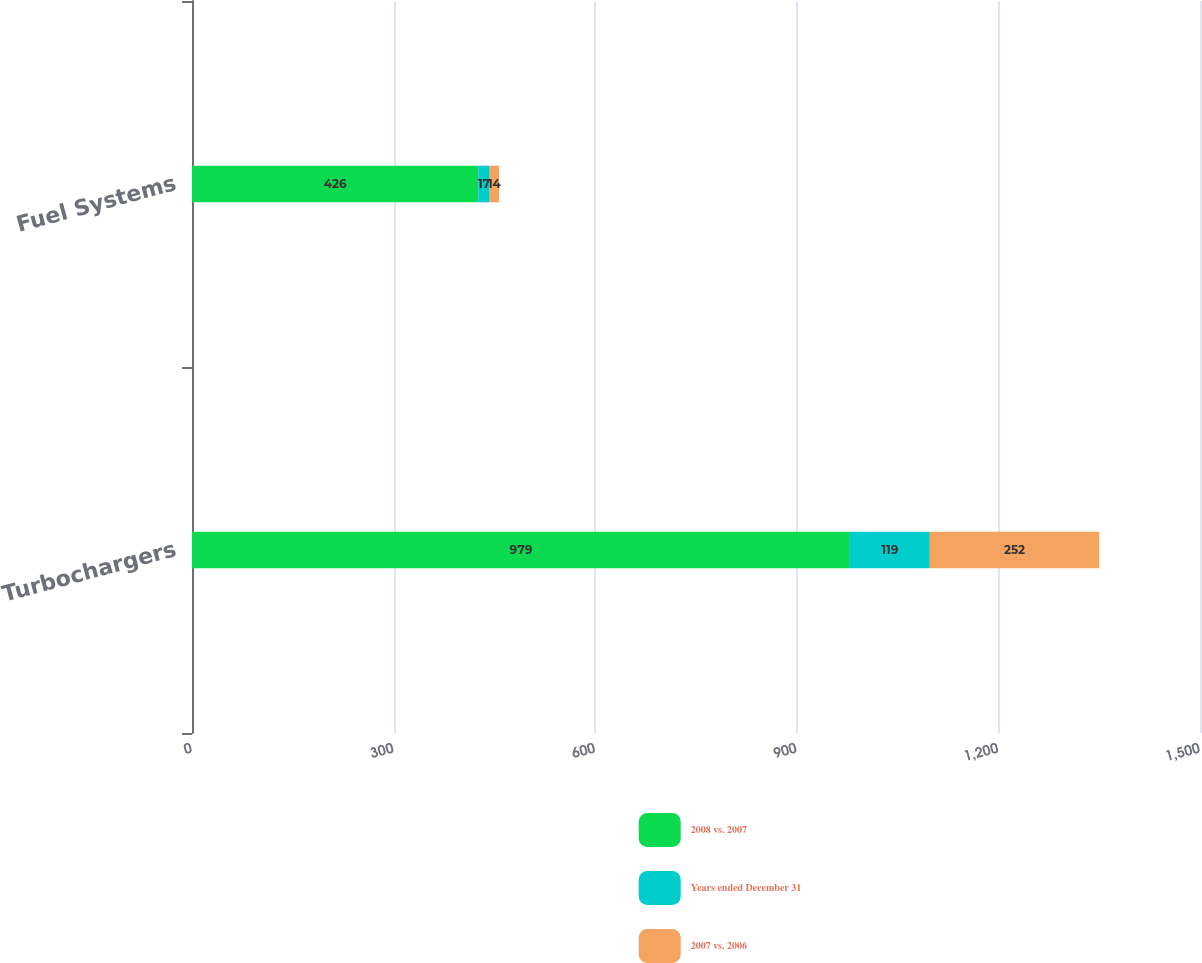Convert chart to OTSL. <chart><loc_0><loc_0><loc_500><loc_500><stacked_bar_chart><ecel><fcel>Turbochargers<fcel>Fuel Systems<nl><fcel>2008 vs. 2007<fcel>979<fcel>426<nl><fcel>Years ended December 31<fcel>119<fcel>17<nl><fcel>2007 vs. 2006<fcel>252<fcel>14<nl></chart> 